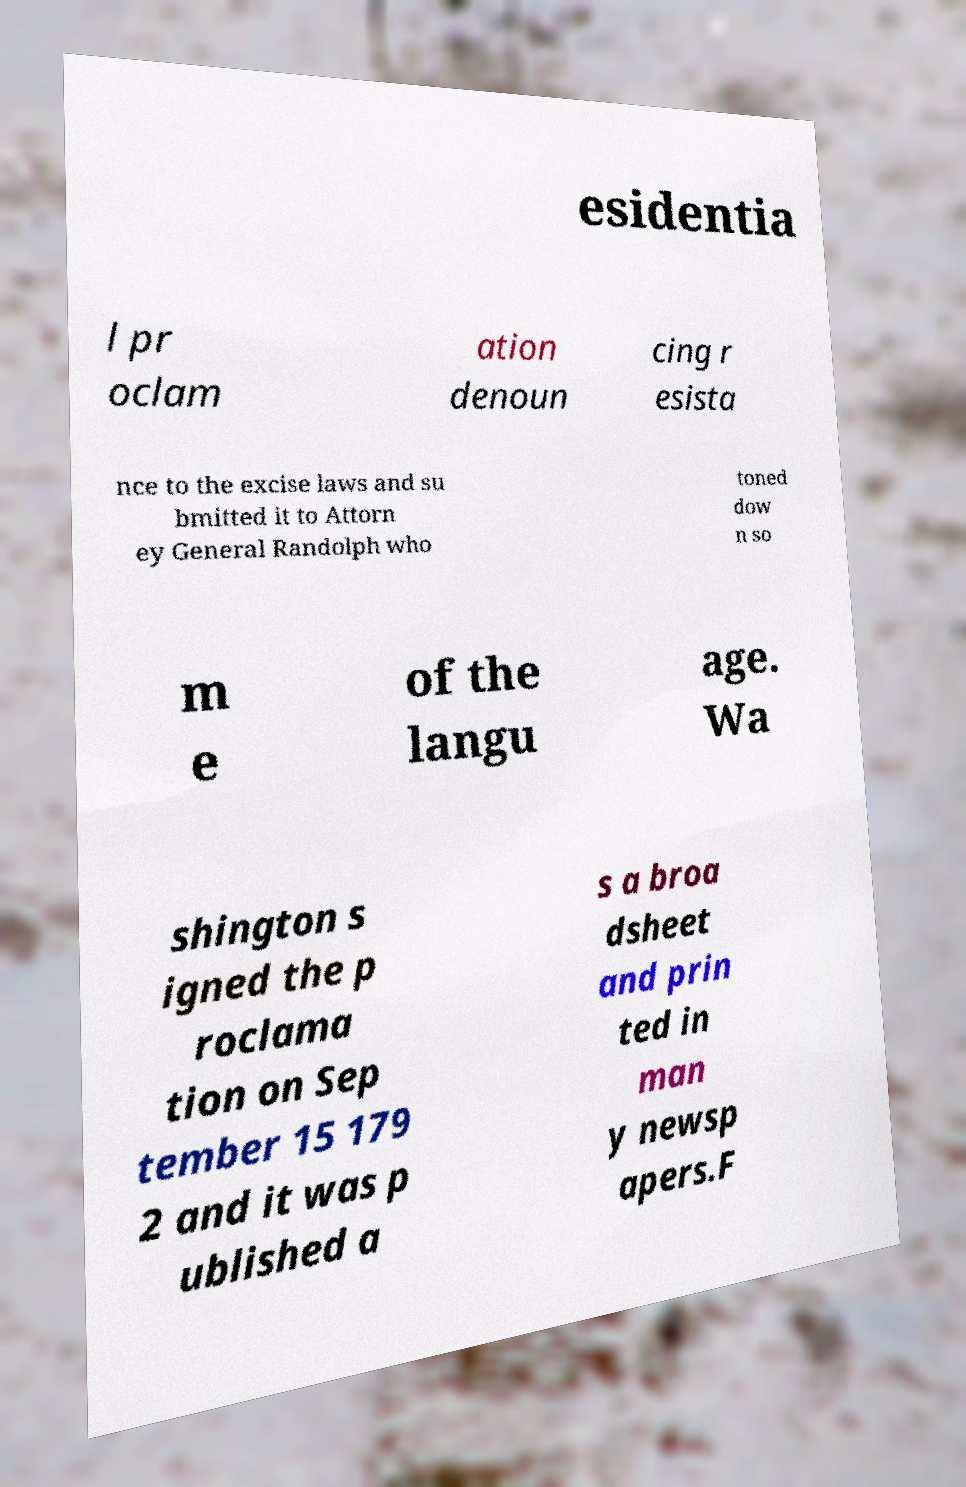Please read and relay the text visible in this image. What does it say? esidentia l pr oclam ation denoun cing r esista nce to the excise laws and su bmitted it to Attorn ey General Randolph who toned dow n so m e of the langu age. Wa shington s igned the p roclama tion on Sep tember 15 179 2 and it was p ublished a s a broa dsheet and prin ted in man y newsp apers.F 